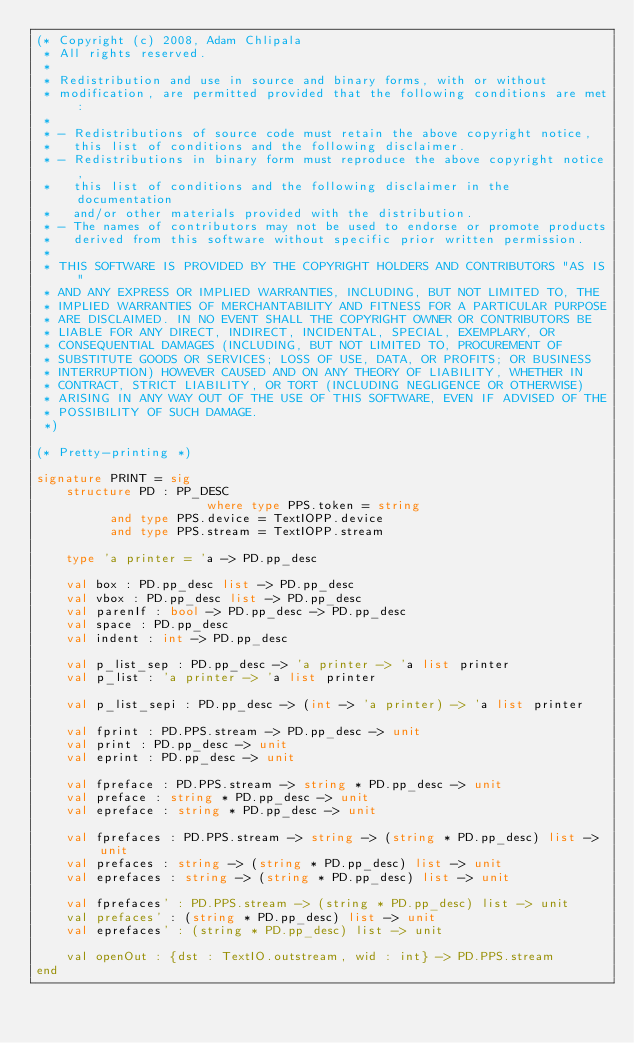Convert code to text. <code><loc_0><loc_0><loc_500><loc_500><_SML_>(* Copyright (c) 2008, Adam Chlipala
 * All rights reserved.
 *
 * Redistribution and use in source and binary forms, with or without
 * modification, are permitted provided that the following conditions are met:
 *
 * - Redistributions of source code must retain the above copyright notice,
 *   this list of conditions and the following disclaimer.
 * - Redistributions in binary form must reproduce the above copyright notice,
 *   this list of conditions and the following disclaimer in the documentation
 *   and/or other materials provided with the distribution.
 * - The names of contributors may not be used to endorse or promote products
 *   derived from this software without specific prior written permission.
 *
 * THIS SOFTWARE IS PROVIDED BY THE COPYRIGHT HOLDERS AND CONTRIBUTORS "AS IS"
 * AND ANY EXPRESS OR IMPLIED WARRANTIES, INCLUDING, BUT NOT LIMITED TO, THE
 * IMPLIED WARRANTIES OF MERCHANTABILITY AND FITNESS FOR A PARTICULAR PURPOSE
 * ARE DISCLAIMED. IN NO EVENT SHALL THE COPYRIGHT OWNER OR CONTRIBUTORS BE
 * LIABLE FOR ANY DIRECT, INDIRECT, INCIDENTAL, SPECIAL, EXEMPLARY, OR 
 * CONSEQUENTIAL DAMAGES (INCLUDING, BUT NOT LIMITED TO, PROCUREMENT OF
 * SUBSTITUTE GOODS OR SERVICES; LOSS OF USE, DATA, OR PROFITS; OR BUSINESS
 * INTERRUPTION) HOWEVER CAUSED AND ON ANY THEORY OF LIABILITY, WHETHER IN
 * CONTRACT, STRICT LIABILITY, OR TORT (INCLUDING NEGLIGENCE OR OTHERWISE)
 * ARISING IN ANY WAY OUT OF THE USE OF THIS SOFTWARE, EVEN IF ADVISED OF THE
 * POSSIBILITY OF SUCH DAMAGE.
 *)

(* Pretty-printing *)

signature PRINT = sig
    structure PD : PP_DESC
                       where type PPS.token = string
          and type PPS.device = TextIOPP.device
          and type PPS.stream = TextIOPP.stream

    type 'a printer = 'a -> PD.pp_desc

    val box : PD.pp_desc list -> PD.pp_desc
    val vbox : PD.pp_desc list -> PD.pp_desc
    val parenIf : bool -> PD.pp_desc -> PD.pp_desc
    val space : PD.pp_desc
    val indent : int -> PD.pp_desc

    val p_list_sep : PD.pp_desc -> 'a printer -> 'a list printer
    val p_list : 'a printer -> 'a list printer

    val p_list_sepi : PD.pp_desc -> (int -> 'a printer) -> 'a list printer

    val fprint : PD.PPS.stream -> PD.pp_desc -> unit
    val print : PD.pp_desc -> unit
    val eprint : PD.pp_desc -> unit

    val fpreface : PD.PPS.stream -> string * PD.pp_desc -> unit
    val preface : string * PD.pp_desc -> unit
    val epreface : string * PD.pp_desc -> unit

    val fprefaces : PD.PPS.stream -> string -> (string * PD.pp_desc) list -> unit
    val prefaces : string -> (string * PD.pp_desc) list -> unit
    val eprefaces : string -> (string * PD.pp_desc) list -> unit

    val fprefaces' : PD.PPS.stream -> (string * PD.pp_desc) list -> unit
    val prefaces' : (string * PD.pp_desc) list -> unit
    val eprefaces' : (string * PD.pp_desc) list -> unit

    val openOut : {dst : TextIO.outstream, wid : int} -> PD.PPS.stream
end
</code> 